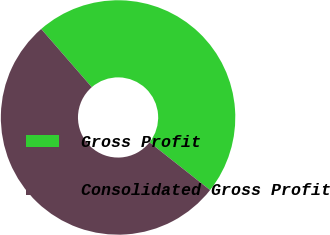Convert chart to OTSL. <chart><loc_0><loc_0><loc_500><loc_500><pie_chart><fcel>Gross Profit<fcel>Consolidated Gross Profit<nl><fcel>47.02%<fcel>52.98%<nl></chart> 